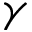<formula> <loc_0><loc_0><loc_500><loc_500>\gamma</formula> 